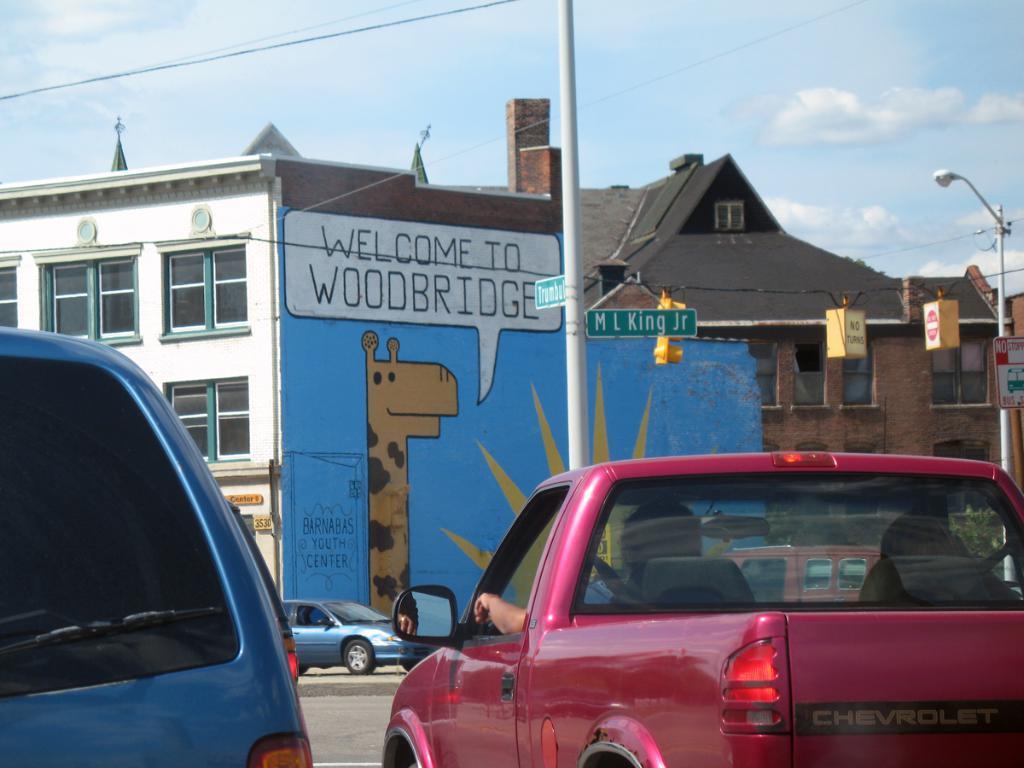Please provide a concise description of this image. These are the two vehicles that are moving on the road and at the down side. In the middle there is a building and it has a painting of a giraffe. At the top it is the sky. 